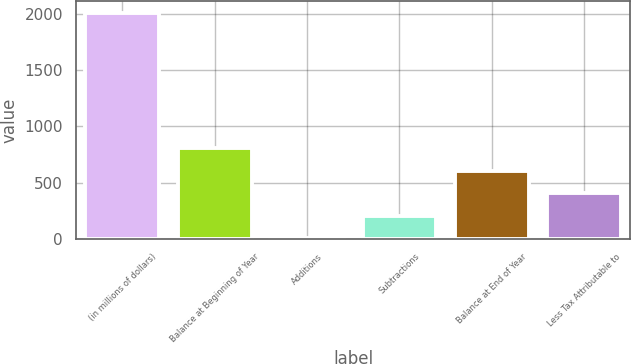Convert chart to OTSL. <chart><loc_0><loc_0><loc_500><loc_500><bar_chart><fcel>(in millions of dollars)<fcel>Balance at Beginning of Year<fcel>Additions<fcel>Subtractions<fcel>Balance at End of Year<fcel>Less Tax Attributable to<nl><fcel>2010<fcel>806.16<fcel>3.6<fcel>204.24<fcel>605.52<fcel>404.88<nl></chart> 